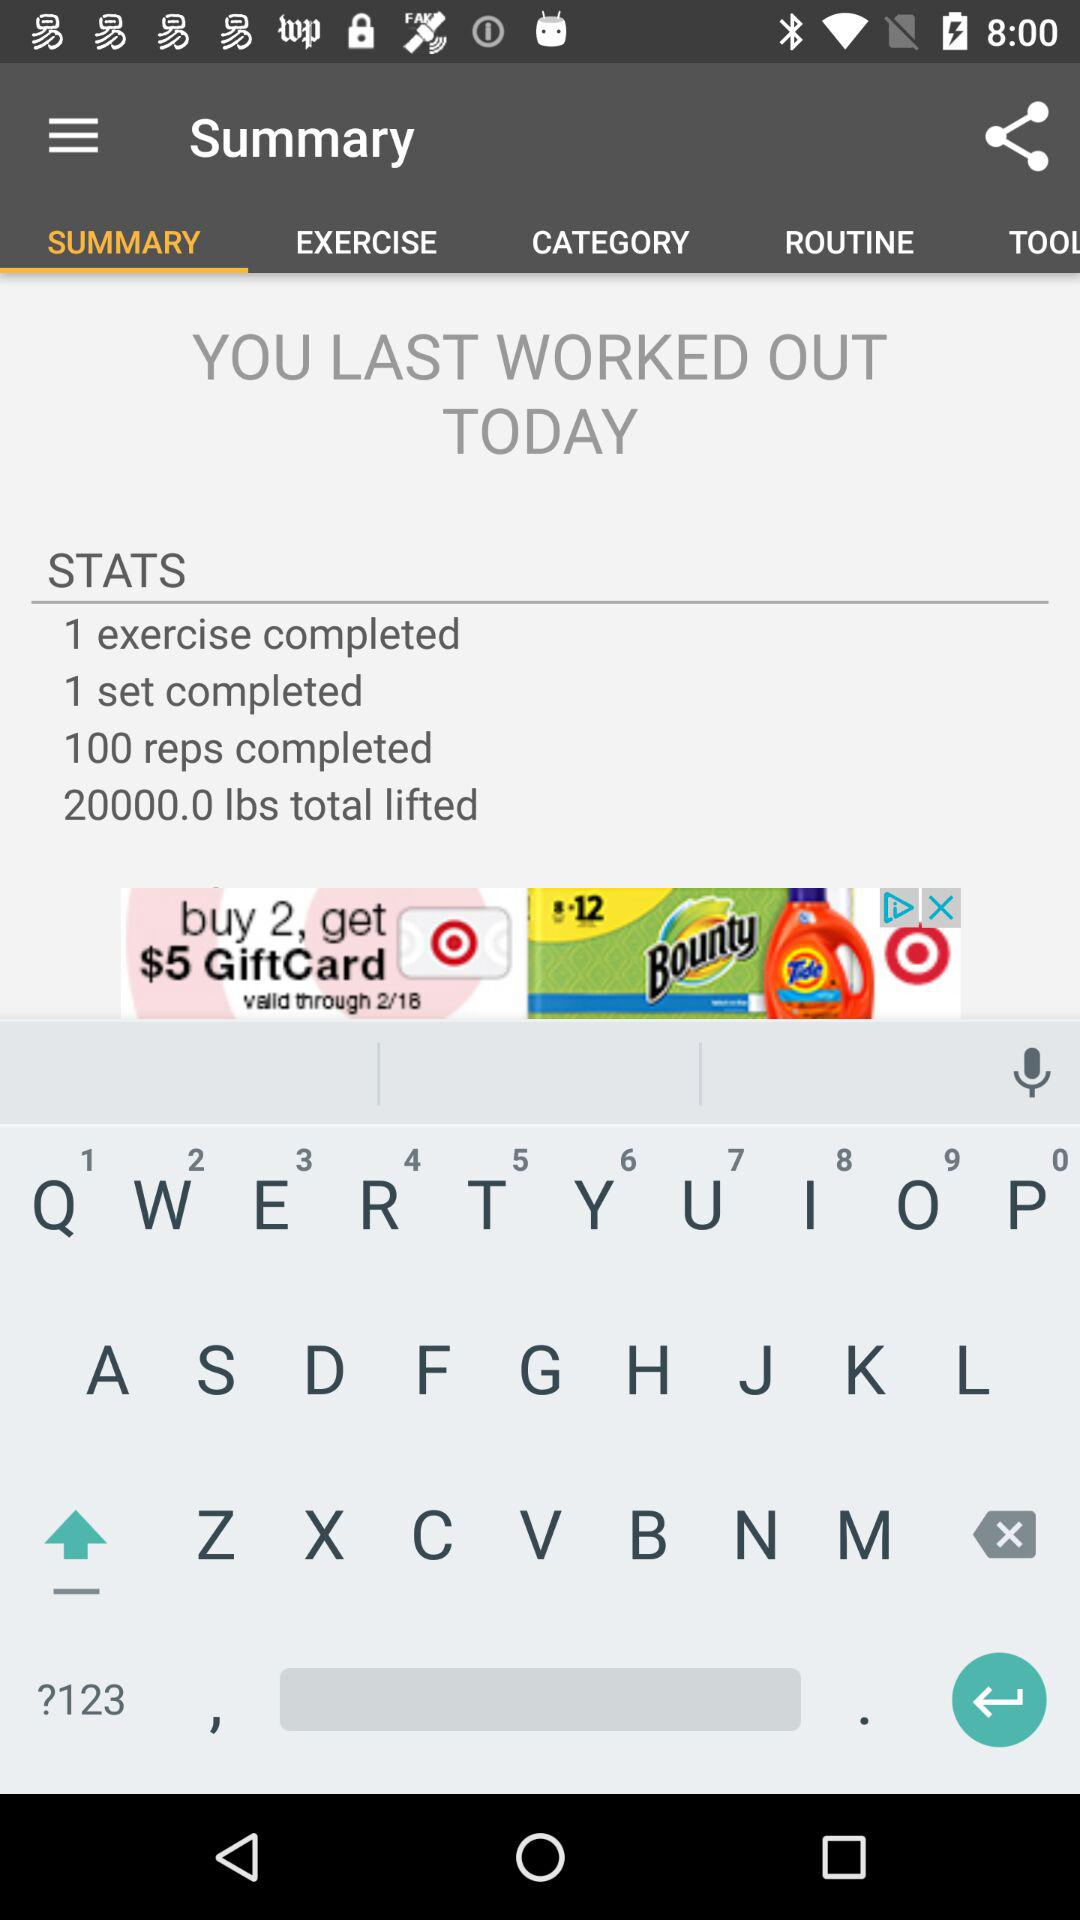How many reps did you complete?
Answer the question using a single word or phrase. 100 